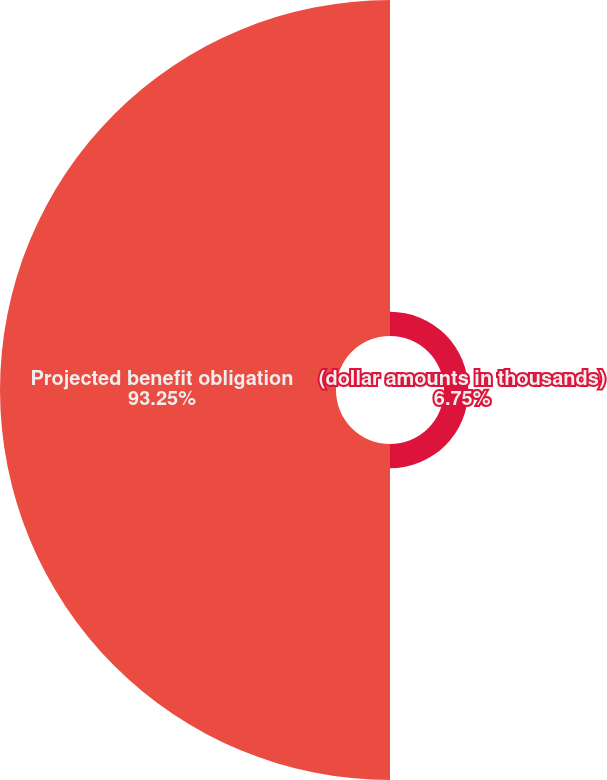<chart> <loc_0><loc_0><loc_500><loc_500><pie_chart><fcel>(dollar amounts in thousands)<fcel>Projected benefit obligation<nl><fcel>6.75%<fcel>93.25%<nl></chart> 